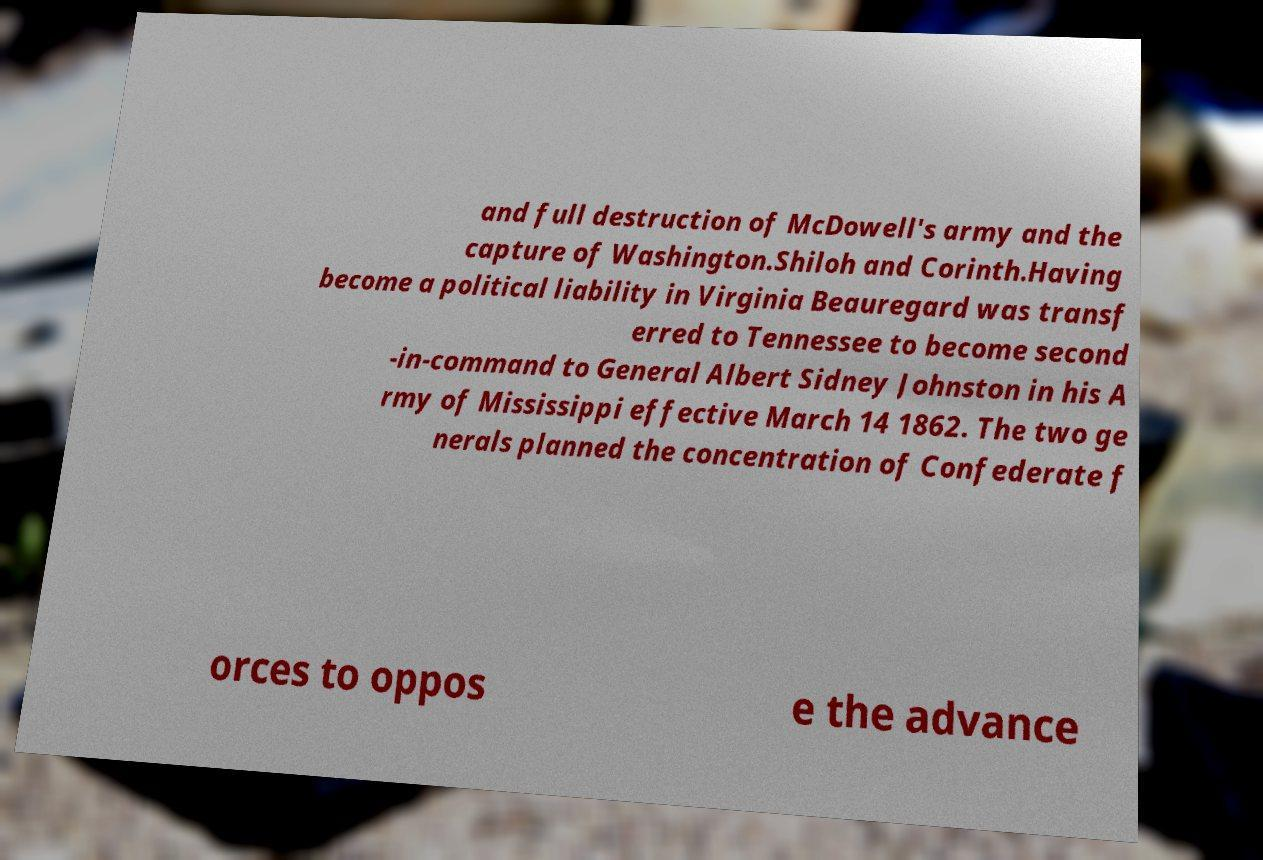Please identify and transcribe the text found in this image. and full destruction of McDowell's army and the capture of Washington.Shiloh and Corinth.Having become a political liability in Virginia Beauregard was transf erred to Tennessee to become second -in-command to General Albert Sidney Johnston in his A rmy of Mississippi effective March 14 1862. The two ge nerals planned the concentration of Confederate f orces to oppos e the advance 